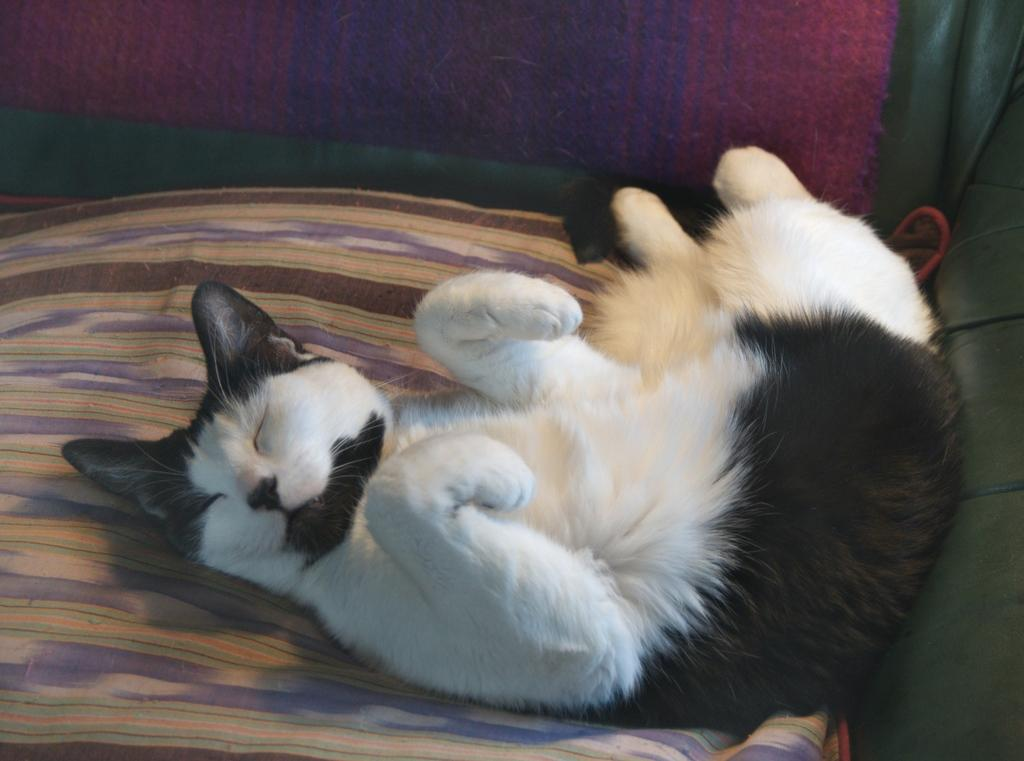What type of animal is in the image? There is a cat in the image. Where is the cat located? The cat is lying on a sofa. What else is on the sofa? There is a blanket on the sofa. In which type of space is the image likely taken? The image is likely taken in a room. What type of star can be seen shining through the window in the image? There is no window or star visible in the image; it features a cat lying on a sofa with a blanket. 